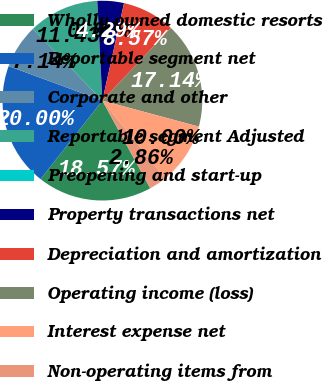<chart> <loc_0><loc_0><loc_500><loc_500><pie_chart><fcel>Wholly owned domestic resorts<fcel>Reportable segment net<fcel>Corporate and other<fcel>Reportable segment Adjusted<fcel>Preopening and start-up<fcel>Property transactions net<fcel>Depreciation and amortization<fcel>Operating income (loss)<fcel>Interest expense net<fcel>Non-operating items from<nl><fcel>18.57%<fcel>20.0%<fcel>7.14%<fcel>11.43%<fcel>0.0%<fcel>4.29%<fcel>8.57%<fcel>17.14%<fcel>10.0%<fcel>2.86%<nl></chart> 